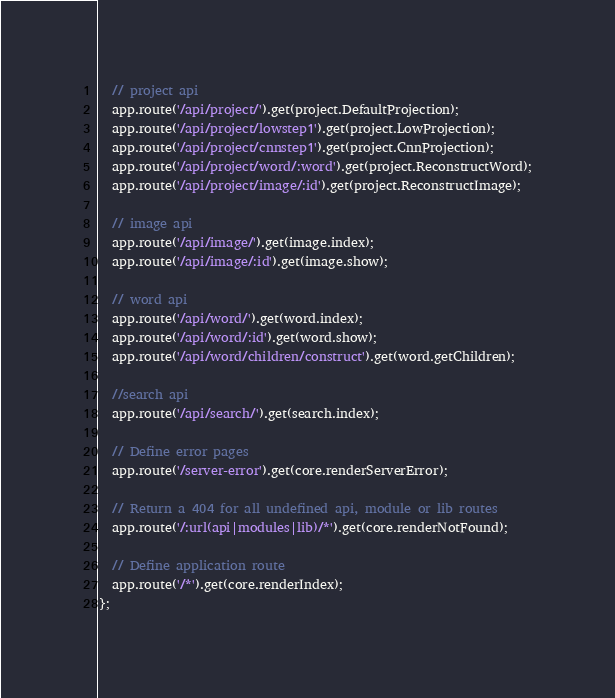<code> <loc_0><loc_0><loc_500><loc_500><_JavaScript_>  // project api
  app.route('/api/project/').get(project.DefaultProjection);
  app.route('/api/project/lowstep1').get(project.LowProjection);
  app.route('/api/project/cnnstep1').get(project.CnnProjection);
  app.route('/api/project/word/:word').get(project.ReconstructWord);
  app.route('/api/project/image/:id').get(project.ReconstructImage);

  // image api
  app.route('/api/image/').get(image.index);
  app.route('/api/image/:id').get(image.show);

  // word api
  app.route('/api/word/').get(word.index);
  app.route('/api/word/:id').get(word.show);
  app.route('/api/word/children/construct').get(word.getChildren);

  //search api
  app.route('/api/search/').get(search.index);

  // Define error pages
  app.route('/server-error').get(core.renderServerError);

  // Return a 404 for all undefined api, module or lib routes
  app.route('/:url(api|modules|lib)/*').get(core.renderNotFound);

  // Define application route
  app.route('/*').get(core.renderIndex);
};
</code> 